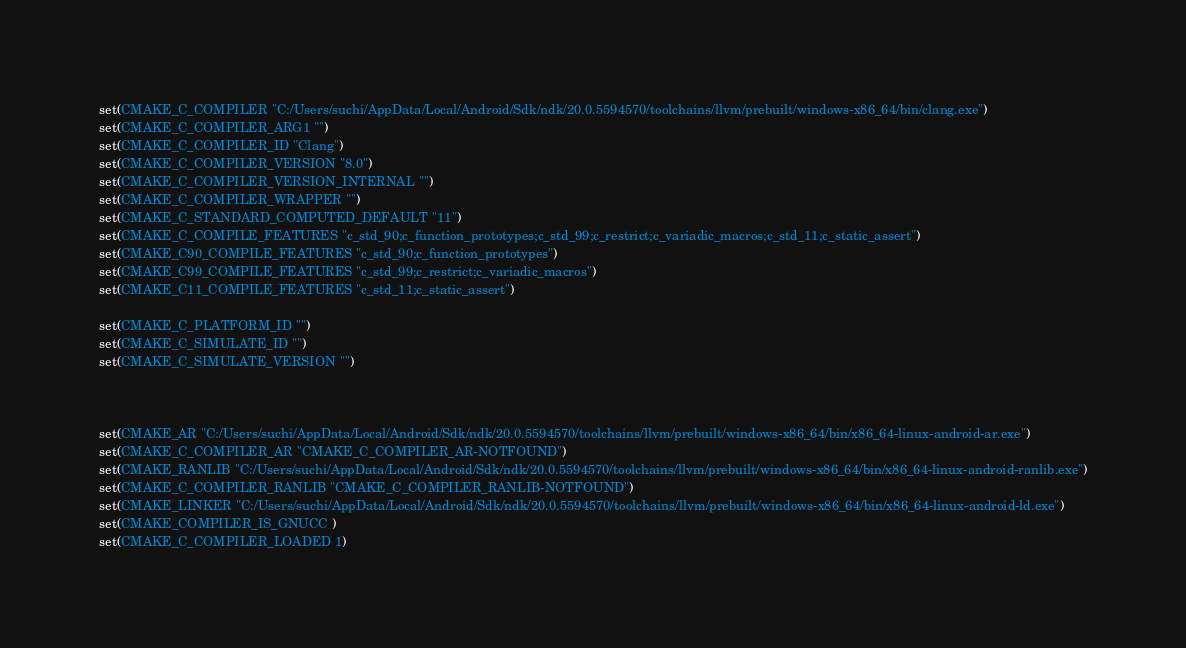<code> <loc_0><loc_0><loc_500><loc_500><_CMake_>set(CMAKE_C_COMPILER "C:/Users/suchi/AppData/Local/Android/Sdk/ndk/20.0.5594570/toolchains/llvm/prebuilt/windows-x86_64/bin/clang.exe")
set(CMAKE_C_COMPILER_ARG1 "")
set(CMAKE_C_COMPILER_ID "Clang")
set(CMAKE_C_COMPILER_VERSION "8.0")
set(CMAKE_C_COMPILER_VERSION_INTERNAL "")
set(CMAKE_C_COMPILER_WRAPPER "")
set(CMAKE_C_STANDARD_COMPUTED_DEFAULT "11")
set(CMAKE_C_COMPILE_FEATURES "c_std_90;c_function_prototypes;c_std_99;c_restrict;c_variadic_macros;c_std_11;c_static_assert")
set(CMAKE_C90_COMPILE_FEATURES "c_std_90;c_function_prototypes")
set(CMAKE_C99_COMPILE_FEATURES "c_std_99;c_restrict;c_variadic_macros")
set(CMAKE_C11_COMPILE_FEATURES "c_std_11;c_static_assert")

set(CMAKE_C_PLATFORM_ID "")
set(CMAKE_C_SIMULATE_ID "")
set(CMAKE_C_SIMULATE_VERSION "")



set(CMAKE_AR "C:/Users/suchi/AppData/Local/Android/Sdk/ndk/20.0.5594570/toolchains/llvm/prebuilt/windows-x86_64/bin/x86_64-linux-android-ar.exe")
set(CMAKE_C_COMPILER_AR "CMAKE_C_COMPILER_AR-NOTFOUND")
set(CMAKE_RANLIB "C:/Users/suchi/AppData/Local/Android/Sdk/ndk/20.0.5594570/toolchains/llvm/prebuilt/windows-x86_64/bin/x86_64-linux-android-ranlib.exe")
set(CMAKE_C_COMPILER_RANLIB "CMAKE_C_COMPILER_RANLIB-NOTFOUND")
set(CMAKE_LINKER "C:/Users/suchi/AppData/Local/Android/Sdk/ndk/20.0.5594570/toolchains/llvm/prebuilt/windows-x86_64/bin/x86_64-linux-android-ld.exe")
set(CMAKE_COMPILER_IS_GNUCC )
set(CMAKE_C_COMPILER_LOADED 1)</code> 